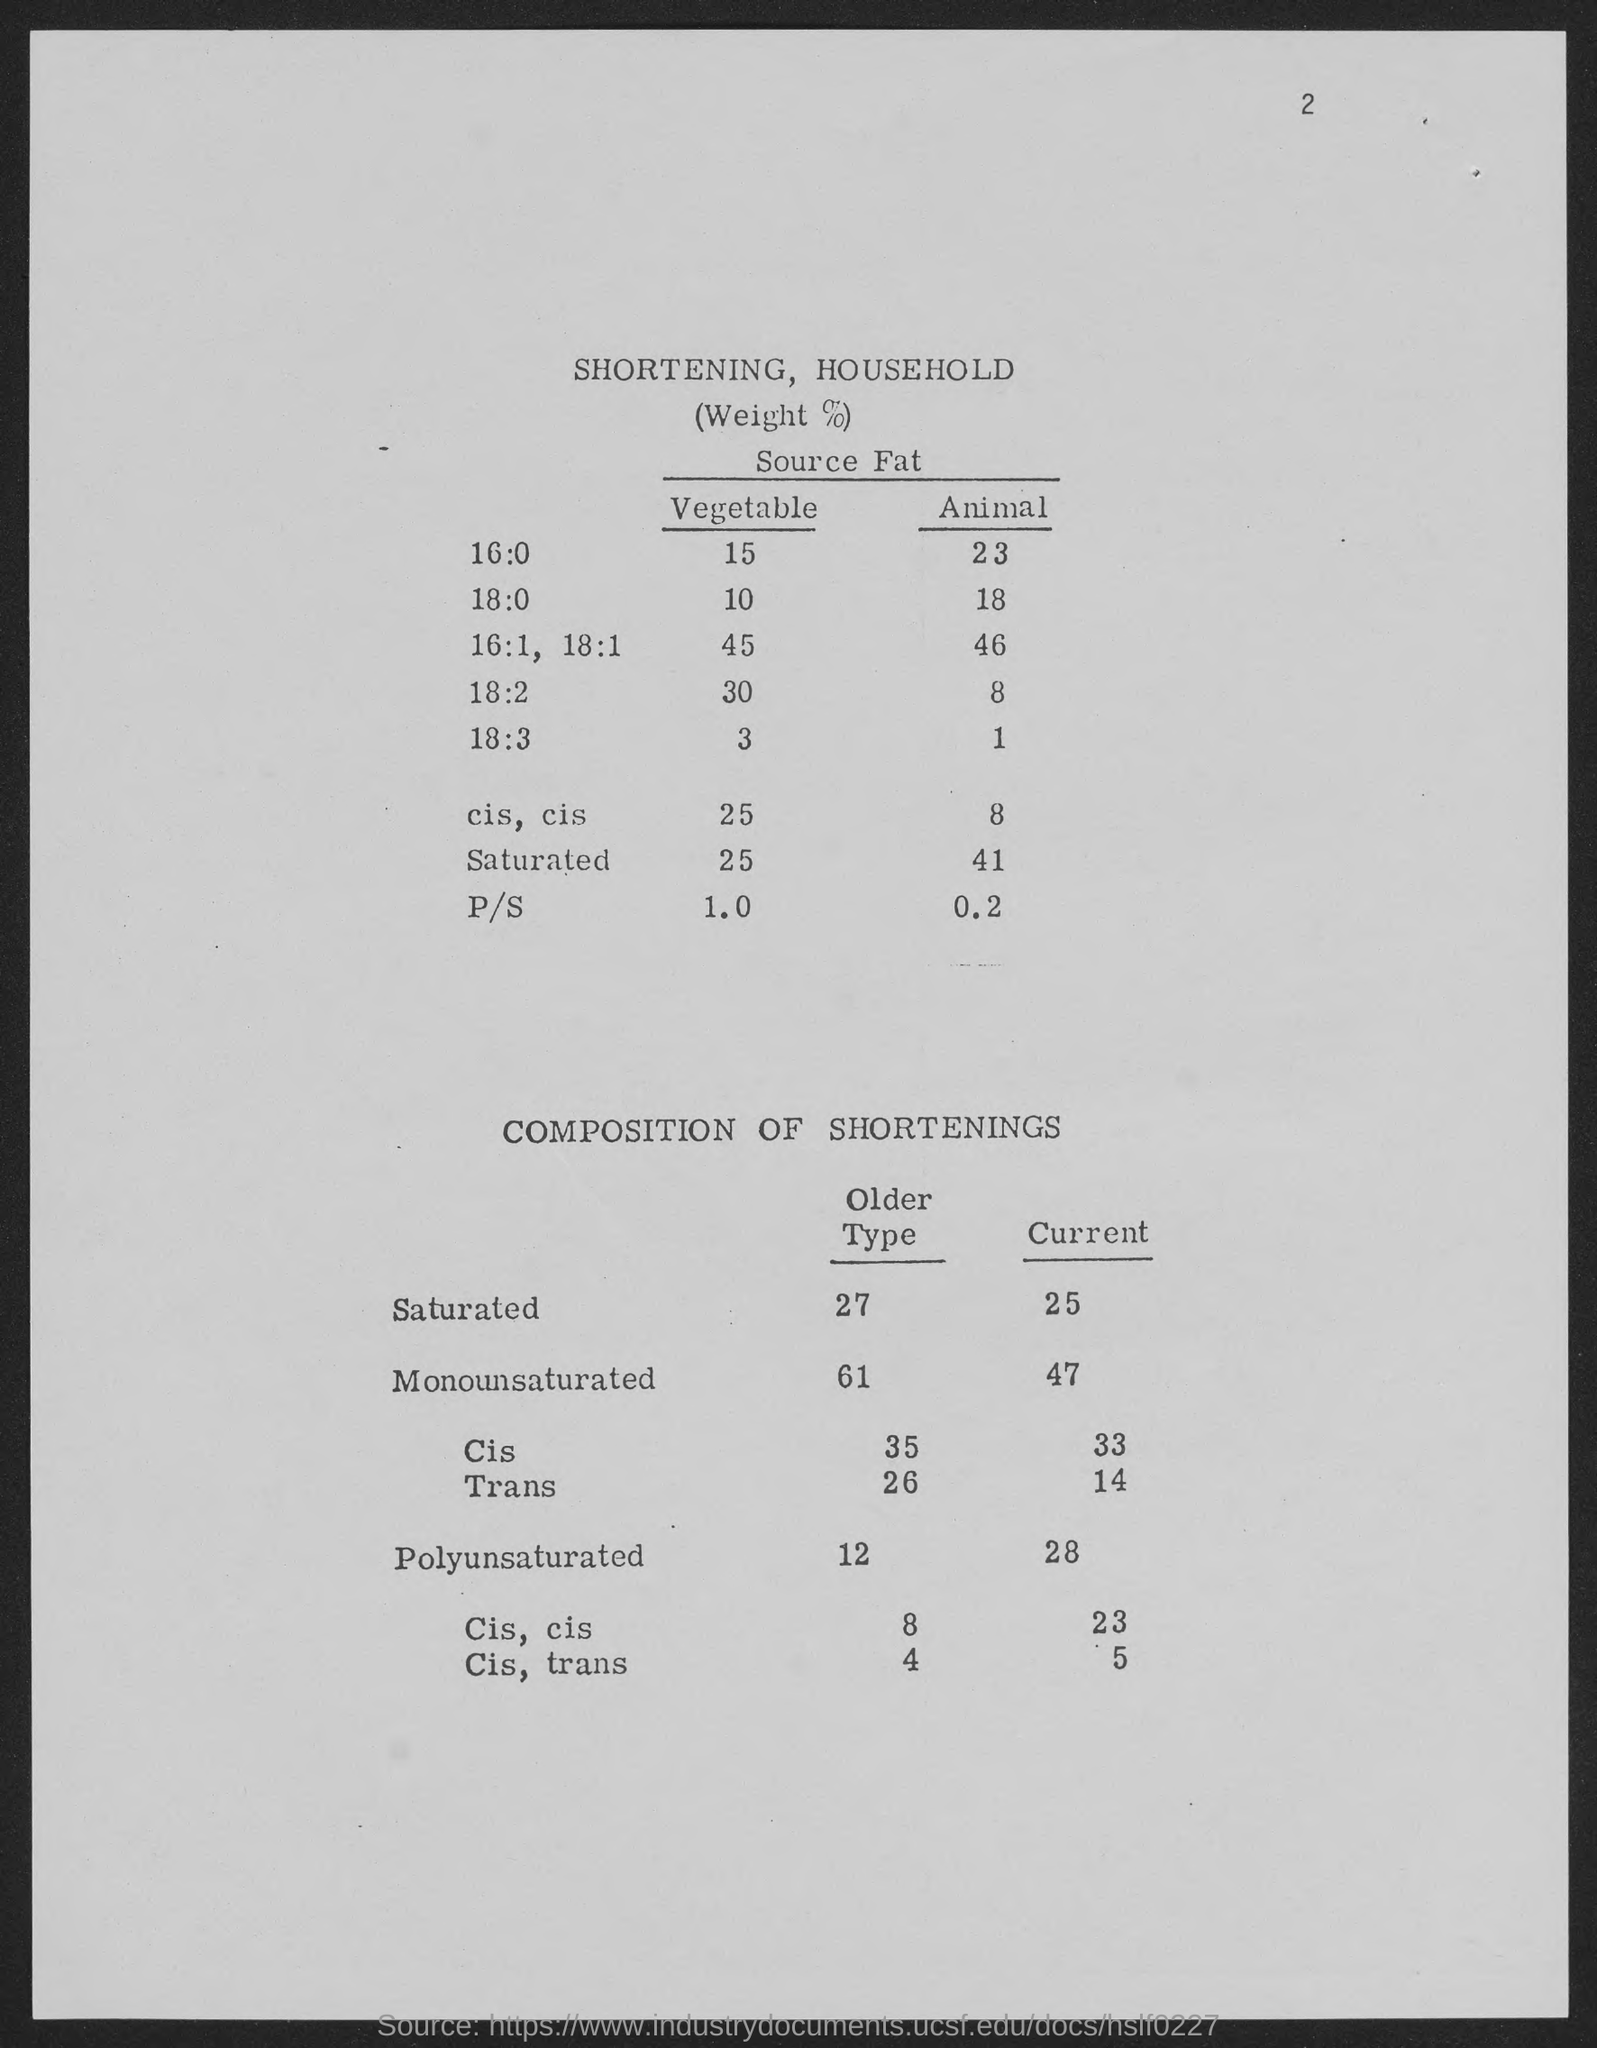What is the number at top-right corner of the page?
Keep it short and to the point. 2. What is the older type in saturated ?
Provide a short and direct response. 27. 